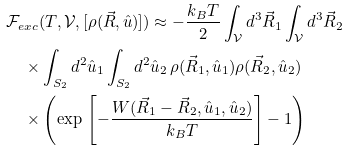<formula> <loc_0><loc_0><loc_500><loc_500>& \mathcal { F } _ { e x c } ( T , \mathcal { V } , [ \rho ( \vec { R } , \hat { u } ) ] ) \approx - \frac { k _ { B } T } { 2 } \int _ { \mathcal { V } } d ^ { 3 } \vec { R } _ { 1 } \int _ { \mathcal { V } } d ^ { 3 } \vec { R } _ { 2 } \\ & \quad \times \int _ { S _ { 2 } } d ^ { 2 } \hat { u } _ { 1 } \int _ { S _ { 2 } } d ^ { 2 } \hat { u } _ { 2 } \, \rho ( \vec { R } _ { 1 } , \hat { u } _ { 1 } ) \rho ( \vec { R } _ { 2 } , \hat { u } _ { 2 } ) \\ & \quad \times \left ( \exp \, \left [ - \frac { W ( \vec { R } _ { 1 } - \vec { R } _ { 2 } , \hat { u } _ { 1 } , \hat { u } _ { 2 } ) } { k _ { B } T } \right ] - 1 \right )</formula> 